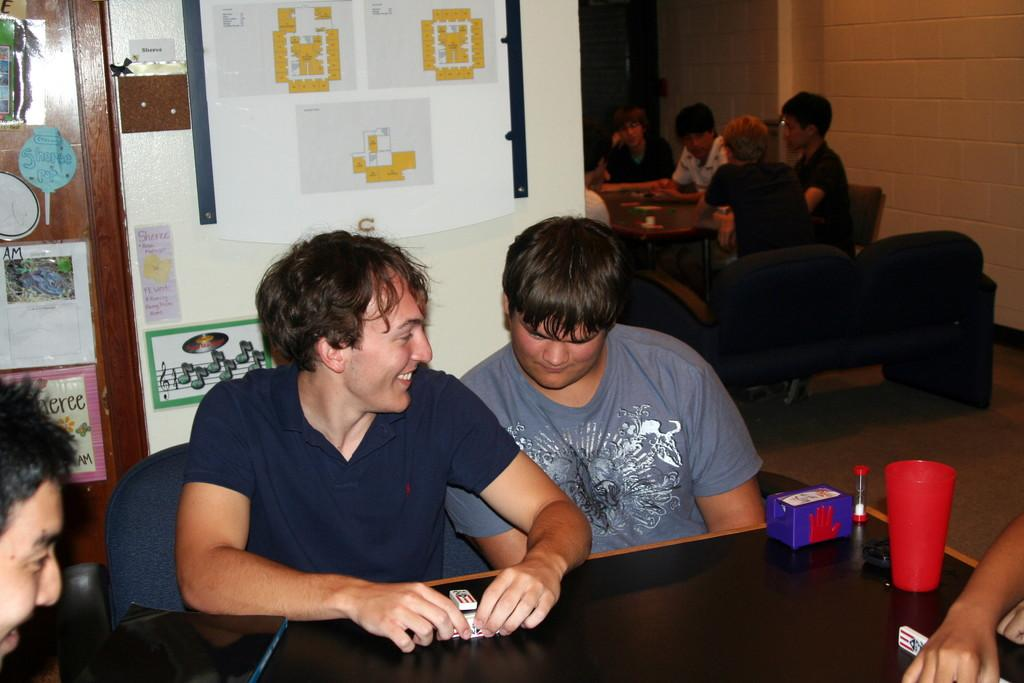How many people are in the image? There are two people in the image. What are the people doing in the image? The people are sitting on chairs. Where are the chairs located in relation to the table? The chairs are in front of a table. What is on the wall behind the people? There are posters on the wall. What type of sugar is being used to sweeten the soda in the image? There is no sugar or soda present in the image. How many times do the people fall off their chairs in the image? The people do not fall off their chairs in the image; they are sitting on them. 